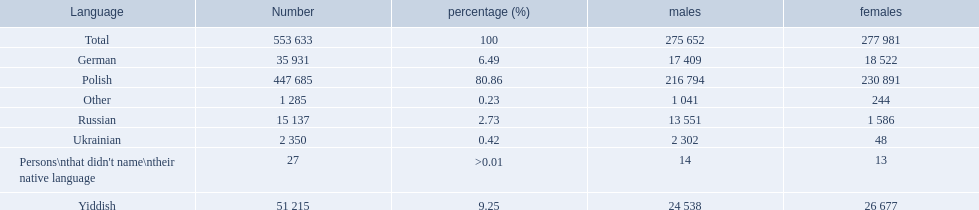What language makes a majority Polish. What the the total number of speakers? 553 633. 